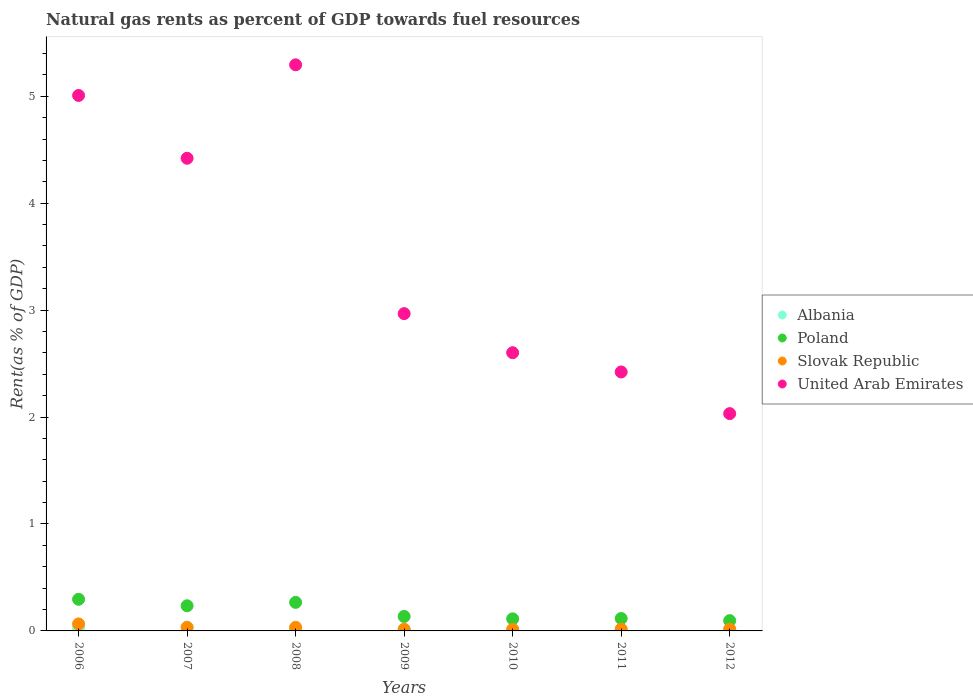How many different coloured dotlines are there?
Keep it short and to the point. 4. Is the number of dotlines equal to the number of legend labels?
Ensure brevity in your answer.  Yes. What is the matural gas rent in Albania in 2008?
Your answer should be very brief. 0.02. Across all years, what is the maximum matural gas rent in Poland?
Ensure brevity in your answer.  0.3. Across all years, what is the minimum matural gas rent in Slovak Republic?
Provide a short and direct response. 0.01. In which year was the matural gas rent in Albania minimum?
Offer a very short reply. 2009. What is the total matural gas rent in Albania in the graph?
Your response must be concise. 0.13. What is the difference between the matural gas rent in Albania in 2007 and that in 2011?
Give a very brief answer. 0.02. What is the difference between the matural gas rent in Albania in 2011 and the matural gas rent in Slovak Republic in 2012?
Keep it short and to the point. -0. What is the average matural gas rent in Poland per year?
Keep it short and to the point. 0.18. In the year 2007, what is the difference between the matural gas rent in Poland and matural gas rent in United Arab Emirates?
Provide a succinct answer. -4.19. What is the ratio of the matural gas rent in Poland in 2008 to that in 2009?
Provide a succinct answer. 1.97. Is the difference between the matural gas rent in Poland in 2008 and 2009 greater than the difference between the matural gas rent in United Arab Emirates in 2008 and 2009?
Your answer should be very brief. No. What is the difference between the highest and the second highest matural gas rent in Slovak Republic?
Offer a terse response. 0.03. What is the difference between the highest and the lowest matural gas rent in Slovak Republic?
Your answer should be compact. 0.05. In how many years, is the matural gas rent in United Arab Emirates greater than the average matural gas rent in United Arab Emirates taken over all years?
Your response must be concise. 3. Is the sum of the matural gas rent in Slovak Republic in 2006 and 2010 greater than the maximum matural gas rent in Poland across all years?
Provide a succinct answer. No. Is it the case that in every year, the sum of the matural gas rent in Albania and matural gas rent in United Arab Emirates  is greater than the sum of matural gas rent in Poland and matural gas rent in Slovak Republic?
Provide a succinct answer. No. Is the matural gas rent in Poland strictly less than the matural gas rent in United Arab Emirates over the years?
Ensure brevity in your answer.  Yes. How many dotlines are there?
Your response must be concise. 4. How many years are there in the graph?
Make the answer very short. 7. What is the difference between two consecutive major ticks on the Y-axis?
Provide a succinct answer. 1. Does the graph contain any zero values?
Give a very brief answer. No. Where does the legend appear in the graph?
Your answer should be very brief. Center right. What is the title of the graph?
Offer a very short reply. Natural gas rents as percent of GDP towards fuel resources. Does "South Africa" appear as one of the legend labels in the graph?
Keep it short and to the point. No. What is the label or title of the X-axis?
Offer a terse response. Years. What is the label or title of the Y-axis?
Make the answer very short. Rent(as % of GDP). What is the Rent(as % of GDP) in Albania in 2006?
Your response must be concise. 0.03. What is the Rent(as % of GDP) of Poland in 2006?
Give a very brief answer. 0.3. What is the Rent(as % of GDP) in Slovak Republic in 2006?
Offer a very short reply. 0.07. What is the Rent(as % of GDP) of United Arab Emirates in 2006?
Offer a very short reply. 5.01. What is the Rent(as % of GDP) of Albania in 2007?
Make the answer very short. 0.03. What is the Rent(as % of GDP) in Poland in 2007?
Make the answer very short. 0.24. What is the Rent(as % of GDP) in Slovak Republic in 2007?
Provide a short and direct response. 0.03. What is the Rent(as % of GDP) in United Arab Emirates in 2007?
Offer a terse response. 4.42. What is the Rent(as % of GDP) in Albania in 2008?
Ensure brevity in your answer.  0.02. What is the Rent(as % of GDP) in Poland in 2008?
Offer a terse response. 0.27. What is the Rent(as % of GDP) of Slovak Republic in 2008?
Give a very brief answer. 0.03. What is the Rent(as % of GDP) in United Arab Emirates in 2008?
Provide a short and direct response. 5.29. What is the Rent(as % of GDP) of Albania in 2009?
Your response must be concise. 0.01. What is the Rent(as % of GDP) in Poland in 2009?
Your answer should be compact. 0.14. What is the Rent(as % of GDP) of Slovak Republic in 2009?
Give a very brief answer. 0.02. What is the Rent(as % of GDP) in United Arab Emirates in 2009?
Your answer should be compact. 2.97. What is the Rent(as % of GDP) in Albania in 2010?
Your response must be concise. 0.01. What is the Rent(as % of GDP) of Poland in 2010?
Provide a short and direct response. 0.11. What is the Rent(as % of GDP) in Slovak Republic in 2010?
Provide a short and direct response. 0.01. What is the Rent(as % of GDP) of United Arab Emirates in 2010?
Your answer should be very brief. 2.6. What is the Rent(as % of GDP) in Albania in 2011?
Your answer should be very brief. 0.01. What is the Rent(as % of GDP) of Poland in 2011?
Keep it short and to the point. 0.12. What is the Rent(as % of GDP) in Slovak Republic in 2011?
Give a very brief answer. 0.02. What is the Rent(as % of GDP) in United Arab Emirates in 2011?
Keep it short and to the point. 2.42. What is the Rent(as % of GDP) in Albania in 2012?
Provide a short and direct response. 0.01. What is the Rent(as % of GDP) in Poland in 2012?
Your answer should be compact. 0.1. What is the Rent(as % of GDP) in Slovak Republic in 2012?
Your answer should be very brief. 0.02. What is the Rent(as % of GDP) of United Arab Emirates in 2012?
Your answer should be compact. 2.03. Across all years, what is the maximum Rent(as % of GDP) of Albania?
Provide a short and direct response. 0.03. Across all years, what is the maximum Rent(as % of GDP) of Poland?
Provide a short and direct response. 0.3. Across all years, what is the maximum Rent(as % of GDP) of Slovak Republic?
Keep it short and to the point. 0.07. Across all years, what is the maximum Rent(as % of GDP) in United Arab Emirates?
Your answer should be very brief. 5.29. Across all years, what is the minimum Rent(as % of GDP) of Albania?
Your response must be concise. 0.01. Across all years, what is the minimum Rent(as % of GDP) of Poland?
Offer a very short reply. 0.1. Across all years, what is the minimum Rent(as % of GDP) of Slovak Republic?
Offer a very short reply. 0.01. Across all years, what is the minimum Rent(as % of GDP) in United Arab Emirates?
Provide a succinct answer. 2.03. What is the total Rent(as % of GDP) of Albania in the graph?
Ensure brevity in your answer.  0.13. What is the total Rent(as % of GDP) in Poland in the graph?
Your response must be concise. 1.26. What is the total Rent(as % of GDP) in Slovak Republic in the graph?
Your answer should be compact. 0.2. What is the total Rent(as % of GDP) in United Arab Emirates in the graph?
Your answer should be compact. 24.75. What is the difference between the Rent(as % of GDP) of Albania in 2006 and that in 2007?
Ensure brevity in your answer.  -0.01. What is the difference between the Rent(as % of GDP) of Poland in 2006 and that in 2007?
Your answer should be very brief. 0.06. What is the difference between the Rent(as % of GDP) in Slovak Republic in 2006 and that in 2007?
Give a very brief answer. 0.03. What is the difference between the Rent(as % of GDP) of United Arab Emirates in 2006 and that in 2007?
Offer a terse response. 0.59. What is the difference between the Rent(as % of GDP) of Albania in 2006 and that in 2008?
Make the answer very short. 0. What is the difference between the Rent(as % of GDP) in Poland in 2006 and that in 2008?
Give a very brief answer. 0.03. What is the difference between the Rent(as % of GDP) in Slovak Republic in 2006 and that in 2008?
Offer a terse response. 0.03. What is the difference between the Rent(as % of GDP) in United Arab Emirates in 2006 and that in 2008?
Give a very brief answer. -0.29. What is the difference between the Rent(as % of GDP) of Albania in 2006 and that in 2009?
Provide a succinct answer. 0.02. What is the difference between the Rent(as % of GDP) in Poland in 2006 and that in 2009?
Offer a terse response. 0.16. What is the difference between the Rent(as % of GDP) of Slovak Republic in 2006 and that in 2009?
Your answer should be very brief. 0.05. What is the difference between the Rent(as % of GDP) in United Arab Emirates in 2006 and that in 2009?
Offer a terse response. 2.04. What is the difference between the Rent(as % of GDP) in Albania in 2006 and that in 2010?
Give a very brief answer. 0.01. What is the difference between the Rent(as % of GDP) in Poland in 2006 and that in 2010?
Ensure brevity in your answer.  0.18. What is the difference between the Rent(as % of GDP) of Slovak Republic in 2006 and that in 2010?
Ensure brevity in your answer.  0.05. What is the difference between the Rent(as % of GDP) of United Arab Emirates in 2006 and that in 2010?
Keep it short and to the point. 2.41. What is the difference between the Rent(as % of GDP) of Albania in 2006 and that in 2011?
Offer a terse response. 0.01. What is the difference between the Rent(as % of GDP) in Poland in 2006 and that in 2011?
Your answer should be compact. 0.18. What is the difference between the Rent(as % of GDP) in Slovak Republic in 2006 and that in 2011?
Your response must be concise. 0.05. What is the difference between the Rent(as % of GDP) in United Arab Emirates in 2006 and that in 2011?
Your answer should be compact. 2.59. What is the difference between the Rent(as % of GDP) in Albania in 2006 and that in 2012?
Keep it short and to the point. 0.01. What is the difference between the Rent(as % of GDP) of Poland in 2006 and that in 2012?
Give a very brief answer. 0.2. What is the difference between the Rent(as % of GDP) of Slovak Republic in 2006 and that in 2012?
Your answer should be compact. 0.05. What is the difference between the Rent(as % of GDP) of United Arab Emirates in 2006 and that in 2012?
Provide a short and direct response. 2.98. What is the difference between the Rent(as % of GDP) in Albania in 2007 and that in 2008?
Offer a terse response. 0.01. What is the difference between the Rent(as % of GDP) in Poland in 2007 and that in 2008?
Keep it short and to the point. -0.03. What is the difference between the Rent(as % of GDP) of Slovak Republic in 2007 and that in 2008?
Your answer should be compact. -0. What is the difference between the Rent(as % of GDP) in United Arab Emirates in 2007 and that in 2008?
Provide a short and direct response. -0.87. What is the difference between the Rent(as % of GDP) in Albania in 2007 and that in 2009?
Offer a terse response. 0.03. What is the difference between the Rent(as % of GDP) of Poland in 2007 and that in 2009?
Your response must be concise. 0.1. What is the difference between the Rent(as % of GDP) of Slovak Republic in 2007 and that in 2009?
Provide a short and direct response. 0.02. What is the difference between the Rent(as % of GDP) in United Arab Emirates in 2007 and that in 2009?
Your answer should be compact. 1.45. What is the difference between the Rent(as % of GDP) of Albania in 2007 and that in 2010?
Your response must be concise. 0.02. What is the difference between the Rent(as % of GDP) of Poland in 2007 and that in 2010?
Make the answer very short. 0.12. What is the difference between the Rent(as % of GDP) of Slovak Republic in 2007 and that in 2010?
Ensure brevity in your answer.  0.02. What is the difference between the Rent(as % of GDP) in United Arab Emirates in 2007 and that in 2010?
Your answer should be very brief. 1.82. What is the difference between the Rent(as % of GDP) in Albania in 2007 and that in 2011?
Give a very brief answer. 0.02. What is the difference between the Rent(as % of GDP) in Poland in 2007 and that in 2011?
Provide a succinct answer. 0.12. What is the difference between the Rent(as % of GDP) in Slovak Republic in 2007 and that in 2011?
Offer a very short reply. 0.02. What is the difference between the Rent(as % of GDP) in United Arab Emirates in 2007 and that in 2011?
Keep it short and to the point. 2. What is the difference between the Rent(as % of GDP) in Albania in 2007 and that in 2012?
Provide a succinct answer. 0.02. What is the difference between the Rent(as % of GDP) of Poland in 2007 and that in 2012?
Offer a terse response. 0.14. What is the difference between the Rent(as % of GDP) of Slovak Republic in 2007 and that in 2012?
Provide a succinct answer. 0.02. What is the difference between the Rent(as % of GDP) in United Arab Emirates in 2007 and that in 2012?
Keep it short and to the point. 2.39. What is the difference between the Rent(as % of GDP) in Albania in 2008 and that in 2009?
Provide a succinct answer. 0.01. What is the difference between the Rent(as % of GDP) in Poland in 2008 and that in 2009?
Ensure brevity in your answer.  0.13. What is the difference between the Rent(as % of GDP) of Slovak Republic in 2008 and that in 2009?
Your answer should be compact. 0.02. What is the difference between the Rent(as % of GDP) in United Arab Emirates in 2008 and that in 2009?
Keep it short and to the point. 2.33. What is the difference between the Rent(as % of GDP) in Albania in 2008 and that in 2010?
Your answer should be very brief. 0.01. What is the difference between the Rent(as % of GDP) in Poland in 2008 and that in 2010?
Give a very brief answer. 0.15. What is the difference between the Rent(as % of GDP) in Slovak Republic in 2008 and that in 2010?
Make the answer very short. 0.02. What is the difference between the Rent(as % of GDP) of United Arab Emirates in 2008 and that in 2010?
Make the answer very short. 2.69. What is the difference between the Rent(as % of GDP) in Albania in 2008 and that in 2011?
Your answer should be compact. 0.01. What is the difference between the Rent(as % of GDP) in Poland in 2008 and that in 2011?
Offer a very short reply. 0.15. What is the difference between the Rent(as % of GDP) of Slovak Republic in 2008 and that in 2011?
Provide a succinct answer. 0.02. What is the difference between the Rent(as % of GDP) in United Arab Emirates in 2008 and that in 2011?
Ensure brevity in your answer.  2.87. What is the difference between the Rent(as % of GDP) of Albania in 2008 and that in 2012?
Your answer should be very brief. 0.01. What is the difference between the Rent(as % of GDP) of Poland in 2008 and that in 2012?
Offer a terse response. 0.17. What is the difference between the Rent(as % of GDP) in Slovak Republic in 2008 and that in 2012?
Make the answer very short. 0.02. What is the difference between the Rent(as % of GDP) of United Arab Emirates in 2008 and that in 2012?
Make the answer very short. 3.26. What is the difference between the Rent(as % of GDP) of Albania in 2009 and that in 2010?
Provide a succinct answer. -0. What is the difference between the Rent(as % of GDP) in Poland in 2009 and that in 2010?
Your answer should be compact. 0.02. What is the difference between the Rent(as % of GDP) in Slovak Republic in 2009 and that in 2010?
Give a very brief answer. 0. What is the difference between the Rent(as % of GDP) of United Arab Emirates in 2009 and that in 2010?
Provide a succinct answer. 0.37. What is the difference between the Rent(as % of GDP) in Albania in 2009 and that in 2011?
Your answer should be compact. -0. What is the difference between the Rent(as % of GDP) of Poland in 2009 and that in 2011?
Offer a very short reply. 0.02. What is the difference between the Rent(as % of GDP) of Slovak Republic in 2009 and that in 2011?
Make the answer very short. -0. What is the difference between the Rent(as % of GDP) in United Arab Emirates in 2009 and that in 2011?
Give a very brief answer. 0.55. What is the difference between the Rent(as % of GDP) of Albania in 2009 and that in 2012?
Offer a terse response. -0. What is the difference between the Rent(as % of GDP) in Poland in 2009 and that in 2012?
Offer a terse response. 0.04. What is the difference between the Rent(as % of GDP) of Slovak Republic in 2009 and that in 2012?
Offer a terse response. -0. What is the difference between the Rent(as % of GDP) of United Arab Emirates in 2009 and that in 2012?
Offer a very short reply. 0.94. What is the difference between the Rent(as % of GDP) of Albania in 2010 and that in 2011?
Provide a succinct answer. -0. What is the difference between the Rent(as % of GDP) in Poland in 2010 and that in 2011?
Your response must be concise. -0. What is the difference between the Rent(as % of GDP) in Slovak Republic in 2010 and that in 2011?
Your answer should be very brief. -0. What is the difference between the Rent(as % of GDP) of United Arab Emirates in 2010 and that in 2011?
Your answer should be very brief. 0.18. What is the difference between the Rent(as % of GDP) of Albania in 2010 and that in 2012?
Your answer should be compact. 0. What is the difference between the Rent(as % of GDP) in Poland in 2010 and that in 2012?
Your answer should be compact. 0.02. What is the difference between the Rent(as % of GDP) in Slovak Republic in 2010 and that in 2012?
Your response must be concise. -0. What is the difference between the Rent(as % of GDP) of United Arab Emirates in 2010 and that in 2012?
Your response must be concise. 0.57. What is the difference between the Rent(as % of GDP) of Albania in 2011 and that in 2012?
Provide a succinct answer. 0. What is the difference between the Rent(as % of GDP) in Poland in 2011 and that in 2012?
Keep it short and to the point. 0.02. What is the difference between the Rent(as % of GDP) in Slovak Republic in 2011 and that in 2012?
Give a very brief answer. -0. What is the difference between the Rent(as % of GDP) of United Arab Emirates in 2011 and that in 2012?
Provide a succinct answer. 0.39. What is the difference between the Rent(as % of GDP) in Albania in 2006 and the Rent(as % of GDP) in Poland in 2007?
Make the answer very short. -0.21. What is the difference between the Rent(as % of GDP) in Albania in 2006 and the Rent(as % of GDP) in Slovak Republic in 2007?
Your response must be concise. -0.01. What is the difference between the Rent(as % of GDP) of Albania in 2006 and the Rent(as % of GDP) of United Arab Emirates in 2007?
Make the answer very short. -4.39. What is the difference between the Rent(as % of GDP) of Poland in 2006 and the Rent(as % of GDP) of Slovak Republic in 2007?
Offer a very short reply. 0.26. What is the difference between the Rent(as % of GDP) of Poland in 2006 and the Rent(as % of GDP) of United Arab Emirates in 2007?
Provide a succinct answer. -4.12. What is the difference between the Rent(as % of GDP) of Slovak Republic in 2006 and the Rent(as % of GDP) of United Arab Emirates in 2007?
Provide a short and direct response. -4.36. What is the difference between the Rent(as % of GDP) of Albania in 2006 and the Rent(as % of GDP) of Poland in 2008?
Provide a short and direct response. -0.24. What is the difference between the Rent(as % of GDP) in Albania in 2006 and the Rent(as % of GDP) in Slovak Republic in 2008?
Your response must be concise. -0.01. What is the difference between the Rent(as % of GDP) of Albania in 2006 and the Rent(as % of GDP) of United Arab Emirates in 2008?
Your response must be concise. -5.27. What is the difference between the Rent(as % of GDP) of Poland in 2006 and the Rent(as % of GDP) of Slovak Republic in 2008?
Your answer should be very brief. 0.26. What is the difference between the Rent(as % of GDP) in Poland in 2006 and the Rent(as % of GDP) in United Arab Emirates in 2008?
Provide a short and direct response. -5. What is the difference between the Rent(as % of GDP) of Slovak Republic in 2006 and the Rent(as % of GDP) of United Arab Emirates in 2008?
Make the answer very short. -5.23. What is the difference between the Rent(as % of GDP) in Albania in 2006 and the Rent(as % of GDP) in Poland in 2009?
Keep it short and to the point. -0.11. What is the difference between the Rent(as % of GDP) in Albania in 2006 and the Rent(as % of GDP) in Slovak Republic in 2009?
Provide a short and direct response. 0.01. What is the difference between the Rent(as % of GDP) in Albania in 2006 and the Rent(as % of GDP) in United Arab Emirates in 2009?
Make the answer very short. -2.94. What is the difference between the Rent(as % of GDP) of Poland in 2006 and the Rent(as % of GDP) of Slovak Republic in 2009?
Your answer should be compact. 0.28. What is the difference between the Rent(as % of GDP) in Poland in 2006 and the Rent(as % of GDP) in United Arab Emirates in 2009?
Offer a very short reply. -2.67. What is the difference between the Rent(as % of GDP) of Slovak Republic in 2006 and the Rent(as % of GDP) of United Arab Emirates in 2009?
Offer a very short reply. -2.9. What is the difference between the Rent(as % of GDP) in Albania in 2006 and the Rent(as % of GDP) in Poland in 2010?
Your answer should be compact. -0.09. What is the difference between the Rent(as % of GDP) in Albania in 2006 and the Rent(as % of GDP) in Slovak Republic in 2010?
Provide a short and direct response. 0.01. What is the difference between the Rent(as % of GDP) of Albania in 2006 and the Rent(as % of GDP) of United Arab Emirates in 2010?
Offer a terse response. -2.58. What is the difference between the Rent(as % of GDP) of Poland in 2006 and the Rent(as % of GDP) of Slovak Republic in 2010?
Provide a short and direct response. 0.28. What is the difference between the Rent(as % of GDP) in Poland in 2006 and the Rent(as % of GDP) in United Arab Emirates in 2010?
Your answer should be very brief. -2.31. What is the difference between the Rent(as % of GDP) in Slovak Republic in 2006 and the Rent(as % of GDP) in United Arab Emirates in 2010?
Provide a succinct answer. -2.54. What is the difference between the Rent(as % of GDP) in Albania in 2006 and the Rent(as % of GDP) in Poland in 2011?
Give a very brief answer. -0.09. What is the difference between the Rent(as % of GDP) in Albania in 2006 and the Rent(as % of GDP) in Slovak Republic in 2011?
Provide a short and direct response. 0.01. What is the difference between the Rent(as % of GDP) in Albania in 2006 and the Rent(as % of GDP) in United Arab Emirates in 2011?
Provide a short and direct response. -2.4. What is the difference between the Rent(as % of GDP) of Poland in 2006 and the Rent(as % of GDP) of Slovak Republic in 2011?
Offer a terse response. 0.28. What is the difference between the Rent(as % of GDP) in Poland in 2006 and the Rent(as % of GDP) in United Arab Emirates in 2011?
Ensure brevity in your answer.  -2.13. What is the difference between the Rent(as % of GDP) of Slovak Republic in 2006 and the Rent(as % of GDP) of United Arab Emirates in 2011?
Offer a terse response. -2.36. What is the difference between the Rent(as % of GDP) of Albania in 2006 and the Rent(as % of GDP) of Poland in 2012?
Give a very brief answer. -0.07. What is the difference between the Rent(as % of GDP) of Albania in 2006 and the Rent(as % of GDP) of Slovak Republic in 2012?
Ensure brevity in your answer.  0.01. What is the difference between the Rent(as % of GDP) of Albania in 2006 and the Rent(as % of GDP) of United Arab Emirates in 2012?
Offer a very short reply. -2.01. What is the difference between the Rent(as % of GDP) of Poland in 2006 and the Rent(as % of GDP) of Slovak Republic in 2012?
Provide a short and direct response. 0.28. What is the difference between the Rent(as % of GDP) in Poland in 2006 and the Rent(as % of GDP) in United Arab Emirates in 2012?
Provide a short and direct response. -1.74. What is the difference between the Rent(as % of GDP) of Slovak Republic in 2006 and the Rent(as % of GDP) of United Arab Emirates in 2012?
Provide a short and direct response. -1.97. What is the difference between the Rent(as % of GDP) of Albania in 2007 and the Rent(as % of GDP) of Poland in 2008?
Your response must be concise. -0.23. What is the difference between the Rent(as % of GDP) in Albania in 2007 and the Rent(as % of GDP) in Slovak Republic in 2008?
Your answer should be very brief. 0. What is the difference between the Rent(as % of GDP) in Albania in 2007 and the Rent(as % of GDP) in United Arab Emirates in 2008?
Ensure brevity in your answer.  -5.26. What is the difference between the Rent(as % of GDP) of Poland in 2007 and the Rent(as % of GDP) of Slovak Republic in 2008?
Your answer should be compact. 0.2. What is the difference between the Rent(as % of GDP) in Poland in 2007 and the Rent(as % of GDP) in United Arab Emirates in 2008?
Provide a short and direct response. -5.06. What is the difference between the Rent(as % of GDP) in Slovak Republic in 2007 and the Rent(as % of GDP) in United Arab Emirates in 2008?
Provide a short and direct response. -5.26. What is the difference between the Rent(as % of GDP) in Albania in 2007 and the Rent(as % of GDP) in Poland in 2009?
Offer a terse response. -0.1. What is the difference between the Rent(as % of GDP) of Albania in 2007 and the Rent(as % of GDP) of Slovak Republic in 2009?
Provide a succinct answer. 0.02. What is the difference between the Rent(as % of GDP) in Albania in 2007 and the Rent(as % of GDP) in United Arab Emirates in 2009?
Keep it short and to the point. -2.93. What is the difference between the Rent(as % of GDP) of Poland in 2007 and the Rent(as % of GDP) of Slovak Republic in 2009?
Make the answer very short. 0.22. What is the difference between the Rent(as % of GDP) in Poland in 2007 and the Rent(as % of GDP) in United Arab Emirates in 2009?
Provide a succinct answer. -2.73. What is the difference between the Rent(as % of GDP) of Slovak Republic in 2007 and the Rent(as % of GDP) of United Arab Emirates in 2009?
Provide a succinct answer. -2.93. What is the difference between the Rent(as % of GDP) in Albania in 2007 and the Rent(as % of GDP) in Poland in 2010?
Offer a terse response. -0.08. What is the difference between the Rent(as % of GDP) in Albania in 2007 and the Rent(as % of GDP) in Slovak Republic in 2010?
Your answer should be compact. 0.02. What is the difference between the Rent(as % of GDP) of Albania in 2007 and the Rent(as % of GDP) of United Arab Emirates in 2010?
Ensure brevity in your answer.  -2.57. What is the difference between the Rent(as % of GDP) in Poland in 2007 and the Rent(as % of GDP) in Slovak Republic in 2010?
Provide a succinct answer. 0.22. What is the difference between the Rent(as % of GDP) in Poland in 2007 and the Rent(as % of GDP) in United Arab Emirates in 2010?
Ensure brevity in your answer.  -2.37. What is the difference between the Rent(as % of GDP) in Slovak Republic in 2007 and the Rent(as % of GDP) in United Arab Emirates in 2010?
Your response must be concise. -2.57. What is the difference between the Rent(as % of GDP) in Albania in 2007 and the Rent(as % of GDP) in Poland in 2011?
Your answer should be compact. -0.08. What is the difference between the Rent(as % of GDP) of Albania in 2007 and the Rent(as % of GDP) of Slovak Republic in 2011?
Your answer should be very brief. 0.02. What is the difference between the Rent(as % of GDP) in Albania in 2007 and the Rent(as % of GDP) in United Arab Emirates in 2011?
Provide a succinct answer. -2.39. What is the difference between the Rent(as % of GDP) in Poland in 2007 and the Rent(as % of GDP) in Slovak Republic in 2011?
Your answer should be compact. 0.22. What is the difference between the Rent(as % of GDP) in Poland in 2007 and the Rent(as % of GDP) in United Arab Emirates in 2011?
Your response must be concise. -2.19. What is the difference between the Rent(as % of GDP) of Slovak Republic in 2007 and the Rent(as % of GDP) of United Arab Emirates in 2011?
Provide a succinct answer. -2.39. What is the difference between the Rent(as % of GDP) in Albania in 2007 and the Rent(as % of GDP) in Poland in 2012?
Ensure brevity in your answer.  -0.06. What is the difference between the Rent(as % of GDP) in Albania in 2007 and the Rent(as % of GDP) in Slovak Republic in 2012?
Provide a short and direct response. 0.02. What is the difference between the Rent(as % of GDP) in Albania in 2007 and the Rent(as % of GDP) in United Arab Emirates in 2012?
Offer a terse response. -2. What is the difference between the Rent(as % of GDP) of Poland in 2007 and the Rent(as % of GDP) of Slovak Republic in 2012?
Make the answer very short. 0.22. What is the difference between the Rent(as % of GDP) of Poland in 2007 and the Rent(as % of GDP) of United Arab Emirates in 2012?
Offer a very short reply. -1.8. What is the difference between the Rent(as % of GDP) in Slovak Republic in 2007 and the Rent(as % of GDP) in United Arab Emirates in 2012?
Your response must be concise. -2. What is the difference between the Rent(as % of GDP) in Albania in 2008 and the Rent(as % of GDP) in Poland in 2009?
Offer a very short reply. -0.11. What is the difference between the Rent(as % of GDP) of Albania in 2008 and the Rent(as % of GDP) of Slovak Republic in 2009?
Offer a terse response. 0.01. What is the difference between the Rent(as % of GDP) of Albania in 2008 and the Rent(as % of GDP) of United Arab Emirates in 2009?
Offer a terse response. -2.95. What is the difference between the Rent(as % of GDP) in Poland in 2008 and the Rent(as % of GDP) in Slovak Republic in 2009?
Give a very brief answer. 0.25. What is the difference between the Rent(as % of GDP) of Poland in 2008 and the Rent(as % of GDP) of United Arab Emirates in 2009?
Keep it short and to the point. -2.7. What is the difference between the Rent(as % of GDP) of Slovak Republic in 2008 and the Rent(as % of GDP) of United Arab Emirates in 2009?
Make the answer very short. -2.93. What is the difference between the Rent(as % of GDP) in Albania in 2008 and the Rent(as % of GDP) in Poland in 2010?
Your answer should be very brief. -0.09. What is the difference between the Rent(as % of GDP) of Albania in 2008 and the Rent(as % of GDP) of Slovak Republic in 2010?
Provide a short and direct response. 0.01. What is the difference between the Rent(as % of GDP) of Albania in 2008 and the Rent(as % of GDP) of United Arab Emirates in 2010?
Provide a short and direct response. -2.58. What is the difference between the Rent(as % of GDP) in Poland in 2008 and the Rent(as % of GDP) in Slovak Republic in 2010?
Make the answer very short. 0.25. What is the difference between the Rent(as % of GDP) of Poland in 2008 and the Rent(as % of GDP) of United Arab Emirates in 2010?
Keep it short and to the point. -2.33. What is the difference between the Rent(as % of GDP) in Slovak Republic in 2008 and the Rent(as % of GDP) in United Arab Emirates in 2010?
Keep it short and to the point. -2.57. What is the difference between the Rent(as % of GDP) of Albania in 2008 and the Rent(as % of GDP) of Poland in 2011?
Provide a succinct answer. -0.09. What is the difference between the Rent(as % of GDP) in Albania in 2008 and the Rent(as % of GDP) in Slovak Republic in 2011?
Offer a very short reply. 0. What is the difference between the Rent(as % of GDP) in Albania in 2008 and the Rent(as % of GDP) in United Arab Emirates in 2011?
Offer a terse response. -2.4. What is the difference between the Rent(as % of GDP) of Poland in 2008 and the Rent(as % of GDP) of Slovak Republic in 2011?
Make the answer very short. 0.25. What is the difference between the Rent(as % of GDP) of Poland in 2008 and the Rent(as % of GDP) of United Arab Emirates in 2011?
Offer a very short reply. -2.15. What is the difference between the Rent(as % of GDP) of Slovak Republic in 2008 and the Rent(as % of GDP) of United Arab Emirates in 2011?
Provide a succinct answer. -2.39. What is the difference between the Rent(as % of GDP) in Albania in 2008 and the Rent(as % of GDP) in Poland in 2012?
Keep it short and to the point. -0.07. What is the difference between the Rent(as % of GDP) of Albania in 2008 and the Rent(as % of GDP) of Slovak Republic in 2012?
Your answer should be very brief. 0. What is the difference between the Rent(as % of GDP) of Albania in 2008 and the Rent(as % of GDP) of United Arab Emirates in 2012?
Your answer should be compact. -2.01. What is the difference between the Rent(as % of GDP) in Poland in 2008 and the Rent(as % of GDP) in Slovak Republic in 2012?
Make the answer very short. 0.25. What is the difference between the Rent(as % of GDP) of Poland in 2008 and the Rent(as % of GDP) of United Arab Emirates in 2012?
Keep it short and to the point. -1.77. What is the difference between the Rent(as % of GDP) of Slovak Republic in 2008 and the Rent(as % of GDP) of United Arab Emirates in 2012?
Provide a short and direct response. -2. What is the difference between the Rent(as % of GDP) of Albania in 2009 and the Rent(as % of GDP) of Poland in 2010?
Provide a short and direct response. -0.1. What is the difference between the Rent(as % of GDP) in Albania in 2009 and the Rent(as % of GDP) in Slovak Republic in 2010?
Keep it short and to the point. -0. What is the difference between the Rent(as % of GDP) in Albania in 2009 and the Rent(as % of GDP) in United Arab Emirates in 2010?
Your answer should be compact. -2.59. What is the difference between the Rent(as % of GDP) of Poland in 2009 and the Rent(as % of GDP) of Slovak Republic in 2010?
Provide a succinct answer. 0.12. What is the difference between the Rent(as % of GDP) in Poland in 2009 and the Rent(as % of GDP) in United Arab Emirates in 2010?
Offer a very short reply. -2.47. What is the difference between the Rent(as % of GDP) in Slovak Republic in 2009 and the Rent(as % of GDP) in United Arab Emirates in 2010?
Keep it short and to the point. -2.59. What is the difference between the Rent(as % of GDP) in Albania in 2009 and the Rent(as % of GDP) in Poland in 2011?
Provide a short and direct response. -0.11. What is the difference between the Rent(as % of GDP) of Albania in 2009 and the Rent(as % of GDP) of Slovak Republic in 2011?
Keep it short and to the point. -0.01. What is the difference between the Rent(as % of GDP) in Albania in 2009 and the Rent(as % of GDP) in United Arab Emirates in 2011?
Your response must be concise. -2.41. What is the difference between the Rent(as % of GDP) of Poland in 2009 and the Rent(as % of GDP) of Slovak Republic in 2011?
Provide a short and direct response. 0.12. What is the difference between the Rent(as % of GDP) of Poland in 2009 and the Rent(as % of GDP) of United Arab Emirates in 2011?
Offer a terse response. -2.29. What is the difference between the Rent(as % of GDP) of Slovak Republic in 2009 and the Rent(as % of GDP) of United Arab Emirates in 2011?
Give a very brief answer. -2.41. What is the difference between the Rent(as % of GDP) in Albania in 2009 and the Rent(as % of GDP) in Poland in 2012?
Your response must be concise. -0.09. What is the difference between the Rent(as % of GDP) of Albania in 2009 and the Rent(as % of GDP) of Slovak Republic in 2012?
Keep it short and to the point. -0.01. What is the difference between the Rent(as % of GDP) of Albania in 2009 and the Rent(as % of GDP) of United Arab Emirates in 2012?
Ensure brevity in your answer.  -2.02. What is the difference between the Rent(as % of GDP) in Poland in 2009 and the Rent(as % of GDP) in Slovak Republic in 2012?
Make the answer very short. 0.12. What is the difference between the Rent(as % of GDP) in Poland in 2009 and the Rent(as % of GDP) in United Arab Emirates in 2012?
Offer a terse response. -1.9. What is the difference between the Rent(as % of GDP) of Slovak Republic in 2009 and the Rent(as % of GDP) of United Arab Emirates in 2012?
Provide a succinct answer. -2.02. What is the difference between the Rent(as % of GDP) of Albania in 2010 and the Rent(as % of GDP) of Poland in 2011?
Provide a succinct answer. -0.1. What is the difference between the Rent(as % of GDP) of Albania in 2010 and the Rent(as % of GDP) of Slovak Republic in 2011?
Keep it short and to the point. -0. What is the difference between the Rent(as % of GDP) of Albania in 2010 and the Rent(as % of GDP) of United Arab Emirates in 2011?
Ensure brevity in your answer.  -2.41. What is the difference between the Rent(as % of GDP) in Poland in 2010 and the Rent(as % of GDP) in Slovak Republic in 2011?
Ensure brevity in your answer.  0.1. What is the difference between the Rent(as % of GDP) of Poland in 2010 and the Rent(as % of GDP) of United Arab Emirates in 2011?
Provide a succinct answer. -2.31. What is the difference between the Rent(as % of GDP) of Slovak Republic in 2010 and the Rent(as % of GDP) of United Arab Emirates in 2011?
Keep it short and to the point. -2.41. What is the difference between the Rent(as % of GDP) of Albania in 2010 and the Rent(as % of GDP) of Poland in 2012?
Make the answer very short. -0.08. What is the difference between the Rent(as % of GDP) in Albania in 2010 and the Rent(as % of GDP) in Slovak Republic in 2012?
Provide a short and direct response. -0. What is the difference between the Rent(as % of GDP) in Albania in 2010 and the Rent(as % of GDP) in United Arab Emirates in 2012?
Keep it short and to the point. -2.02. What is the difference between the Rent(as % of GDP) of Poland in 2010 and the Rent(as % of GDP) of Slovak Republic in 2012?
Make the answer very short. 0.1. What is the difference between the Rent(as % of GDP) of Poland in 2010 and the Rent(as % of GDP) of United Arab Emirates in 2012?
Your response must be concise. -1.92. What is the difference between the Rent(as % of GDP) of Slovak Republic in 2010 and the Rent(as % of GDP) of United Arab Emirates in 2012?
Your answer should be compact. -2.02. What is the difference between the Rent(as % of GDP) of Albania in 2011 and the Rent(as % of GDP) of Poland in 2012?
Your answer should be compact. -0.08. What is the difference between the Rent(as % of GDP) in Albania in 2011 and the Rent(as % of GDP) in Slovak Republic in 2012?
Keep it short and to the point. -0. What is the difference between the Rent(as % of GDP) of Albania in 2011 and the Rent(as % of GDP) of United Arab Emirates in 2012?
Keep it short and to the point. -2.02. What is the difference between the Rent(as % of GDP) in Poland in 2011 and the Rent(as % of GDP) in Slovak Republic in 2012?
Give a very brief answer. 0.1. What is the difference between the Rent(as % of GDP) of Poland in 2011 and the Rent(as % of GDP) of United Arab Emirates in 2012?
Give a very brief answer. -1.92. What is the difference between the Rent(as % of GDP) in Slovak Republic in 2011 and the Rent(as % of GDP) in United Arab Emirates in 2012?
Your response must be concise. -2.02. What is the average Rent(as % of GDP) in Albania per year?
Keep it short and to the point. 0.02. What is the average Rent(as % of GDP) in Poland per year?
Make the answer very short. 0.18. What is the average Rent(as % of GDP) of Slovak Republic per year?
Keep it short and to the point. 0.03. What is the average Rent(as % of GDP) in United Arab Emirates per year?
Your response must be concise. 3.54. In the year 2006, what is the difference between the Rent(as % of GDP) of Albania and Rent(as % of GDP) of Poland?
Keep it short and to the point. -0.27. In the year 2006, what is the difference between the Rent(as % of GDP) in Albania and Rent(as % of GDP) in Slovak Republic?
Your response must be concise. -0.04. In the year 2006, what is the difference between the Rent(as % of GDP) of Albania and Rent(as % of GDP) of United Arab Emirates?
Your answer should be compact. -4.98. In the year 2006, what is the difference between the Rent(as % of GDP) of Poland and Rent(as % of GDP) of Slovak Republic?
Keep it short and to the point. 0.23. In the year 2006, what is the difference between the Rent(as % of GDP) of Poland and Rent(as % of GDP) of United Arab Emirates?
Offer a terse response. -4.71. In the year 2006, what is the difference between the Rent(as % of GDP) of Slovak Republic and Rent(as % of GDP) of United Arab Emirates?
Provide a short and direct response. -4.94. In the year 2007, what is the difference between the Rent(as % of GDP) of Albania and Rent(as % of GDP) of Poland?
Your answer should be compact. -0.2. In the year 2007, what is the difference between the Rent(as % of GDP) in Albania and Rent(as % of GDP) in Slovak Republic?
Provide a succinct answer. 0. In the year 2007, what is the difference between the Rent(as % of GDP) of Albania and Rent(as % of GDP) of United Arab Emirates?
Make the answer very short. -4.39. In the year 2007, what is the difference between the Rent(as % of GDP) of Poland and Rent(as % of GDP) of Slovak Republic?
Your answer should be compact. 0.2. In the year 2007, what is the difference between the Rent(as % of GDP) of Poland and Rent(as % of GDP) of United Arab Emirates?
Offer a terse response. -4.19. In the year 2007, what is the difference between the Rent(as % of GDP) of Slovak Republic and Rent(as % of GDP) of United Arab Emirates?
Ensure brevity in your answer.  -4.39. In the year 2008, what is the difference between the Rent(as % of GDP) in Albania and Rent(as % of GDP) in Poland?
Your answer should be compact. -0.25. In the year 2008, what is the difference between the Rent(as % of GDP) in Albania and Rent(as % of GDP) in Slovak Republic?
Give a very brief answer. -0.01. In the year 2008, what is the difference between the Rent(as % of GDP) in Albania and Rent(as % of GDP) in United Arab Emirates?
Offer a terse response. -5.27. In the year 2008, what is the difference between the Rent(as % of GDP) of Poland and Rent(as % of GDP) of Slovak Republic?
Your response must be concise. 0.23. In the year 2008, what is the difference between the Rent(as % of GDP) of Poland and Rent(as % of GDP) of United Arab Emirates?
Provide a succinct answer. -5.03. In the year 2008, what is the difference between the Rent(as % of GDP) of Slovak Republic and Rent(as % of GDP) of United Arab Emirates?
Your answer should be compact. -5.26. In the year 2009, what is the difference between the Rent(as % of GDP) of Albania and Rent(as % of GDP) of Poland?
Give a very brief answer. -0.13. In the year 2009, what is the difference between the Rent(as % of GDP) in Albania and Rent(as % of GDP) in Slovak Republic?
Your response must be concise. -0.01. In the year 2009, what is the difference between the Rent(as % of GDP) of Albania and Rent(as % of GDP) of United Arab Emirates?
Keep it short and to the point. -2.96. In the year 2009, what is the difference between the Rent(as % of GDP) in Poland and Rent(as % of GDP) in Slovak Republic?
Provide a succinct answer. 0.12. In the year 2009, what is the difference between the Rent(as % of GDP) of Poland and Rent(as % of GDP) of United Arab Emirates?
Give a very brief answer. -2.83. In the year 2009, what is the difference between the Rent(as % of GDP) in Slovak Republic and Rent(as % of GDP) in United Arab Emirates?
Give a very brief answer. -2.95. In the year 2010, what is the difference between the Rent(as % of GDP) in Albania and Rent(as % of GDP) in Poland?
Offer a very short reply. -0.1. In the year 2010, what is the difference between the Rent(as % of GDP) in Albania and Rent(as % of GDP) in Slovak Republic?
Ensure brevity in your answer.  -0. In the year 2010, what is the difference between the Rent(as % of GDP) of Albania and Rent(as % of GDP) of United Arab Emirates?
Keep it short and to the point. -2.59. In the year 2010, what is the difference between the Rent(as % of GDP) of Poland and Rent(as % of GDP) of Slovak Republic?
Keep it short and to the point. 0.1. In the year 2010, what is the difference between the Rent(as % of GDP) in Poland and Rent(as % of GDP) in United Arab Emirates?
Your answer should be compact. -2.49. In the year 2010, what is the difference between the Rent(as % of GDP) of Slovak Republic and Rent(as % of GDP) of United Arab Emirates?
Give a very brief answer. -2.59. In the year 2011, what is the difference between the Rent(as % of GDP) of Albania and Rent(as % of GDP) of Poland?
Make the answer very short. -0.1. In the year 2011, what is the difference between the Rent(as % of GDP) of Albania and Rent(as % of GDP) of Slovak Republic?
Ensure brevity in your answer.  -0. In the year 2011, what is the difference between the Rent(as % of GDP) in Albania and Rent(as % of GDP) in United Arab Emirates?
Your response must be concise. -2.41. In the year 2011, what is the difference between the Rent(as % of GDP) in Poland and Rent(as % of GDP) in Slovak Republic?
Offer a terse response. 0.1. In the year 2011, what is the difference between the Rent(as % of GDP) in Poland and Rent(as % of GDP) in United Arab Emirates?
Make the answer very short. -2.31. In the year 2011, what is the difference between the Rent(as % of GDP) in Slovak Republic and Rent(as % of GDP) in United Arab Emirates?
Give a very brief answer. -2.41. In the year 2012, what is the difference between the Rent(as % of GDP) of Albania and Rent(as % of GDP) of Poland?
Offer a terse response. -0.08. In the year 2012, what is the difference between the Rent(as % of GDP) of Albania and Rent(as % of GDP) of Slovak Republic?
Give a very brief answer. -0. In the year 2012, what is the difference between the Rent(as % of GDP) in Albania and Rent(as % of GDP) in United Arab Emirates?
Make the answer very short. -2.02. In the year 2012, what is the difference between the Rent(as % of GDP) in Poland and Rent(as % of GDP) in Slovak Republic?
Your response must be concise. 0.08. In the year 2012, what is the difference between the Rent(as % of GDP) in Poland and Rent(as % of GDP) in United Arab Emirates?
Your answer should be compact. -1.94. In the year 2012, what is the difference between the Rent(as % of GDP) in Slovak Republic and Rent(as % of GDP) in United Arab Emirates?
Offer a terse response. -2.02. What is the ratio of the Rent(as % of GDP) in Albania in 2006 to that in 2007?
Your response must be concise. 0.74. What is the ratio of the Rent(as % of GDP) in Poland in 2006 to that in 2007?
Ensure brevity in your answer.  1.26. What is the ratio of the Rent(as % of GDP) of Slovak Republic in 2006 to that in 2007?
Your answer should be compact. 2. What is the ratio of the Rent(as % of GDP) in United Arab Emirates in 2006 to that in 2007?
Ensure brevity in your answer.  1.13. What is the ratio of the Rent(as % of GDP) of Albania in 2006 to that in 2008?
Offer a terse response. 1.2. What is the ratio of the Rent(as % of GDP) of Poland in 2006 to that in 2008?
Your answer should be compact. 1.11. What is the ratio of the Rent(as % of GDP) of Slovak Republic in 2006 to that in 2008?
Provide a short and direct response. 1.95. What is the ratio of the Rent(as % of GDP) in United Arab Emirates in 2006 to that in 2008?
Your answer should be compact. 0.95. What is the ratio of the Rent(as % of GDP) in Albania in 2006 to that in 2009?
Your answer should be very brief. 2.63. What is the ratio of the Rent(as % of GDP) of Poland in 2006 to that in 2009?
Ensure brevity in your answer.  2.19. What is the ratio of the Rent(as % of GDP) in Slovak Republic in 2006 to that in 2009?
Make the answer very short. 4.11. What is the ratio of the Rent(as % of GDP) of United Arab Emirates in 2006 to that in 2009?
Keep it short and to the point. 1.69. What is the ratio of the Rent(as % of GDP) of Albania in 2006 to that in 2010?
Provide a short and direct response. 1.83. What is the ratio of the Rent(as % of GDP) of Poland in 2006 to that in 2010?
Offer a terse response. 2.62. What is the ratio of the Rent(as % of GDP) of Slovak Republic in 2006 to that in 2010?
Give a very brief answer. 4.52. What is the ratio of the Rent(as % of GDP) of United Arab Emirates in 2006 to that in 2010?
Offer a terse response. 1.92. What is the ratio of the Rent(as % of GDP) in Albania in 2006 to that in 2011?
Your response must be concise. 1.75. What is the ratio of the Rent(as % of GDP) in Poland in 2006 to that in 2011?
Offer a very short reply. 2.55. What is the ratio of the Rent(as % of GDP) in Slovak Republic in 2006 to that in 2011?
Make the answer very short. 3.92. What is the ratio of the Rent(as % of GDP) of United Arab Emirates in 2006 to that in 2011?
Your response must be concise. 2.07. What is the ratio of the Rent(as % of GDP) in Albania in 2006 to that in 2012?
Offer a terse response. 1.93. What is the ratio of the Rent(as % of GDP) of Poland in 2006 to that in 2012?
Give a very brief answer. 3.07. What is the ratio of the Rent(as % of GDP) of Slovak Republic in 2006 to that in 2012?
Provide a short and direct response. 3.82. What is the ratio of the Rent(as % of GDP) of United Arab Emirates in 2006 to that in 2012?
Ensure brevity in your answer.  2.46. What is the ratio of the Rent(as % of GDP) in Albania in 2007 to that in 2008?
Offer a terse response. 1.62. What is the ratio of the Rent(as % of GDP) in Poland in 2007 to that in 2008?
Your answer should be compact. 0.88. What is the ratio of the Rent(as % of GDP) in United Arab Emirates in 2007 to that in 2008?
Your response must be concise. 0.83. What is the ratio of the Rent(as % of GDP) in Albania in 2007 to that in 2009?
Provide a short and direct response. 3.55. What is the ratio of the Rent(as % of GDP) of Poland in 2007 to that in 2009?
Ensure brevity in your answer.  1.74. What is the ratio of the Rent(as % of GDP) of Slovak Republic in 2007 to that in 2009?
Your response must be concise. 2.06. What is the ratio of the Rent(as % of GDP) of United Arab Emirates in 2007 to that in 2009?
Offer a terse response. 1.49. What is the ratio of the Rent(as % of GDP) of Albania in 2007 to that in 2010?
Your response must be concise. 2.46. What is the ratio of the Rent(as % of GDP) of Poland in 2007 to that in 2010?
Your response must be concise. 2.08. What is the ratio of the Rent(as % of GDP) of Slovak Republic in 2007 to that in 2010?
Keep it short and to the point. 2.26. What is the ratio of the Rent(as % of GDP) of United Arab Emirates in 2007 to that in 2010?
Your answer should be very brief. 1.7. What is the ratio of the Rent(as % of GDP) of Albania in 2007 to that in 2011?
Your response must be concise. 2.36. What is the ratio of the Rent(as % of GDP) of Poland in 2007 to that in 2011?
Offer a terse response. 2.02. What is the ratio of the Rent(as % of GDP) of Slovak Republic in 2007 to that in 2011?
Ensure brevity in your answer.  1.96. What is the ratio of the Rent(as % of GDP) in United Arab Emirates in 2007 to that in 2011?
Your answer should be compact. 1.83. What is the ratio of the Rent(as % of GDP) in Albania in 2007 to that in 2012?
Keep it short and to the point. 2.6. What is the ratio of the Rent(as % of GDP) of Poland in 2007 to that in 2012?
Ensure brevity in your answer.  2.44. What is the ratio of the Rent(as % of GDP) of Slovak Republic in 2007 to that in 2012?
Offer a very short reply. 1.91. What is the ratio of the Rent(as % of GDP) in United Arab Emirates in 2007 to that in 2012?
Your response must be concise. 2.18. What is the ratio of the Rent(as % of GDP) in Albania in 2008 to that in 2009?
Keep it short and to the point. 2.19. What is the ratio of the Rent(as % of GDP) of Poland in 2008 to that in 2009?
Offer a very short reply. 1.97. What is the ratio of the Rent(as % of GDP) of Slovak Republic in 2008 to that in 2009?
Offer a very short reply. 2.11. What is the ratio of the Rent(as % of GDP) of United Arab Emirates in 2008 to that in 2009?
Your answer should be very brief. 1.78. What is the ratio of the Rent(as % of GDP) of Albania in 2008 to that in 2010?
Give a very brief answer. 1.52. What is the ratio of the Rent(as % of GDP) of Poland in 2008 to that in 2010?
Give a very brief answer. 2.36. What is the ratio of the Rent(as % of GDP) in Slovak Republic in 2008 to that in 2010?
Offer a very short reply. 2.32. What is the ratio of the Rent(as % of GDP) in United Arab Emirates in 2008 to that in 2010?
Your answer should be compact. 2.03. What is the ratio of the Rent(as % of GDP) in Albania in 2008 to that in 2011?
Offer a terse response. 1.45. What is the ratio of the Rent(as % of GDP) of Poland in 2008 to that in 2011?
Your answer should be very brief. 2.3. What is the ratio of the Rent(as % of GDP) of Slovak Republic in 2008 to that in 2011?
Make the answer very short. 2.01. What is the ratio of the Rent(as % of GDP) of United Arab Emirates in 2008 to that in 2011?
Provide a succinct answer. 2.19. What is the ratio of the Rent(as % of GDP) of Albania in 2008 to that in 2012?
Offer a terse response. 1.6. What is the ratio of the Rent(as % of GDP) of Poland in 2008 to that in 2012?
Offer a very short reply. 2.77. What is the ratio of the Rent(as % of GDP) of Slovak Republic in 2008 to that in 2012?
Provide a succinct answer. 1.96. What is the ratio of the Rent(as % of GDP) in United Arab Emirates in 2008 to that in 2012?
Make the answer very short. 2.6. What is the ratio of the Rent(as % of GDP) in Albania in 2009 to that in 2010?
Provide a short and direct response. 0.69. What is the ratio of the Rent(as % of GDP) in Poland in 2009 to that in 2010?
Offer a terse response. 1.2. What is the ratio of the Rent(as % of GDP) of Slovak Republic in 2009 to that in 2010?
Ensure brevity in your answer.  1.1. What is the ratio of the Rent(as % of GDP) of United Arab Emirates in 2009 to that in 2010?
Provide a short and direct response. 1.14. What is the ratio of the Rent(as % of GDP) of Albania in 2009 to that in 2011?
Provide a short and direct response. 0.67. What is the ratio of the Rent(as % of GDP) of Poland in 2009 to that in 2011?
Keep it short and to the point. 1.17. What is the ratio of the Rent(as % of GDP) in Slovak Republic in 2009 to that in 2011?
Ensure brevity in your answer.  0.95. What is the ratio of the Rent(as % of GDP) of United Arab Emirates in 2009 to that in 2011?
Provide a succinct answer. 1.23. What is the ratio of the Rent(as % of GDP) of Albania in 2009 to that in 2012?
Your response must be concise. 0.73. What is the ratio of the Rent(as % of GDP) in Poland in 2009 to that in 2012?
Ensure brevity in your answer.  1.41. What is the ratio of the Rent(as % of GDP) in Slovak Republic in 2009 to that in 2012?
Offer a terse response. 0.93. What is the ratio of the Rent(as % of GDP) of United Arab Emirates in 2009 to that in 2012?
Your response must be concise. 1.46. What is the ratio of the Rent(as % of GDP) of Albania in 2010 to that in 2011?
Offer a very short reply. 0.96. What is the ratio of the Rent(as % of GDP) of Poland in 2010 to that in 2011?
Offer a very short reply. 0.97. What is the ratio of the Rent(as % of GDP) in Slovak Republic in 2010 to that in 2011?
Ensure brevity in your answer.  0.87. What is the ratio of the Rent(as % of GDP) in United Arab Emirates in 2010 to that in 2011?
Offer a terse response. 1.07. What is the ratio of the Rent(as % of GDP) of Albania in 2010 to that in 2012?
Give a very brief answer. 1.06. What is the ratio of the Rent(as % of GDP) of Poland in 2010 to that in 2012?
Offer a terse response. 1.17. What is the ratio of the Rent(as % of GDP) in Slovak Republic in 2010 to that in 2012?
Ensure brevity in your answer.  0.84. What is the ratio of the Rent(as % of GDP) in United Arab Emirates in 2010 to that in 2012?
Keep it short and to the point. 1.28. What is the ratio of the Rent(as % of GDP) of Albania in 2011 to that in 2012?
Provide a succinct answer. 1.1. What is the ratio of the Rent(as % of GDP) in Poland in 2011 to that in 2012?
Provide a short and direct response. 1.21. What is the ratio of the Rent(as % of GDP) in Slovak Republic in 2011 to that in 2012?
Offer a terse response. 0.97. What is the ratio of the Rent(as % of GDP) in United Arab Emirates in 2011 to that in 2012?
Ensure brevity in your answer.  1.19. What is the difference between the highest and the second highest Rent(as % of GDP) of Albania?
Offer a terse response. 0.01. What is the difference between the highest and the second highest Rent(as % of GDP) in Poland?
Provide a short and direct response. 0.03. What is the difference between the highest and the second highest Rent(as % of GDP) in Slovak Republic?
Your answer should be very brief. 0.03. What is the difference between the highest and the second highest Rent(as % of GDP) in United Arab Emirates?
Keep it short and to the point. 0.29. What is the difference between the highest and the lowest Rent(as % of GDP) of Albania?
Your answer should be compact. 0.03. What is the difference between the highest and the lowest Rent(as % of GDP) of Poland?
Give a very brief answer. 0.2. What is the difference between the highest and the lowest Rent(as % of GDP) in Slovak Republic?
Ensure brevity in your answer.  0.05. What is the difference between the highest and the lowest Rent(as % of GDP) of United Arab Emirates?
Your answer should be very brief. 3.26. 